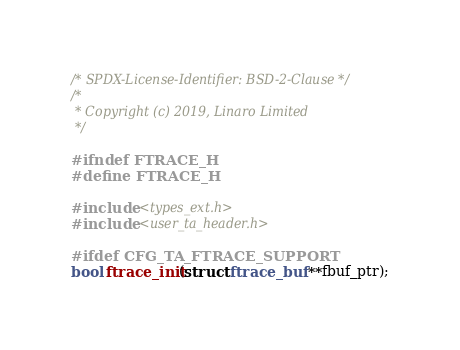Convert code to text. <code><loc_0><loc_0><loc_500><loc_500><_C_>/* SPDX-License-Identifier: BSD-2-Clause */
/*
 * Copyright (c) 2019, Linaro Limited
 */

#ifndef FTRACE_H
#define FTRACE_H

#include <types_ext.h>
#include <user_ta_header.h>

#ifdef CFG_TA_FTRACE_SUPPORT
bool ftrace_init(struct ftrace_buf **fbuf_ptr);</code> 